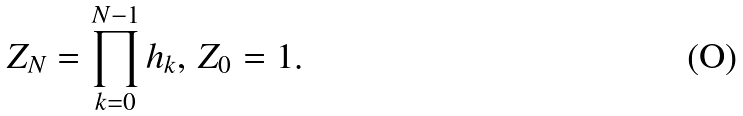<formula> <loc_0><loc_0><loc_500><loc_500>Z _ { N } = \prod _ { k = 0 } ^ { N - 1 } h _ { k } , \, Z _ { 0 } = 1 .</formula> 